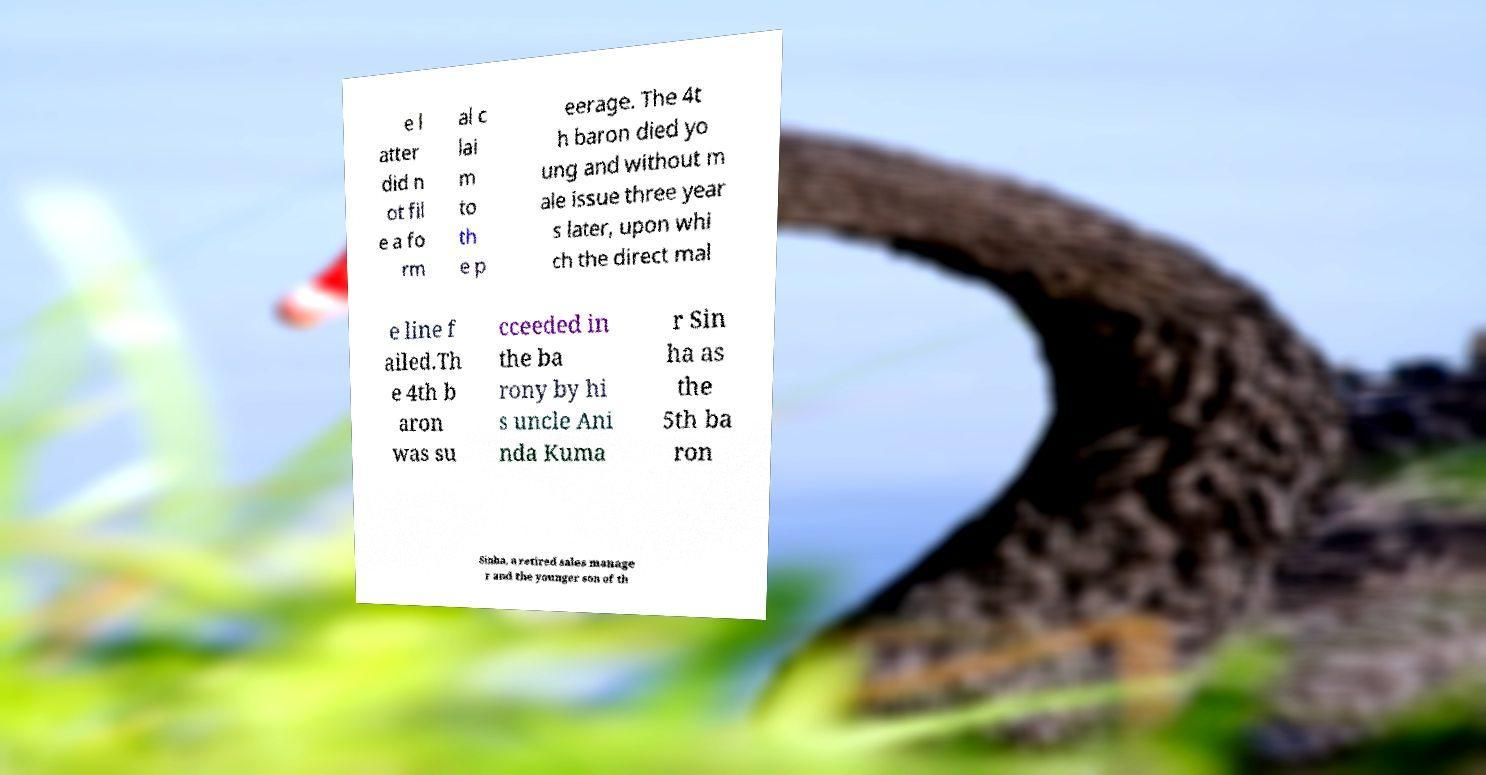Could you assist in decoding the text presented in this image and type it out clearly? e l atter did n ot fil e a fo rm al c lai m to th e p eerage. The 4t h baron died yo ung and without m ale issue three year s later, upon whi ch the direct mal e line f ailed.Th e 4th b aron was su cceeded in the ba rony by hi s uncle Ani nda Kuma r Sin ha as the 5th ba ron Sinha, a retired sales manage r and the younger son of th 